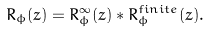<formula> <loc_0><loc_0><loc_500><loc_500>R _ { \phi } ( z ) = R ^ { \infty } _ { \phi } ( z ) * R ^ { f i n i t e } _ { \phi } ( z ) .</formula> 